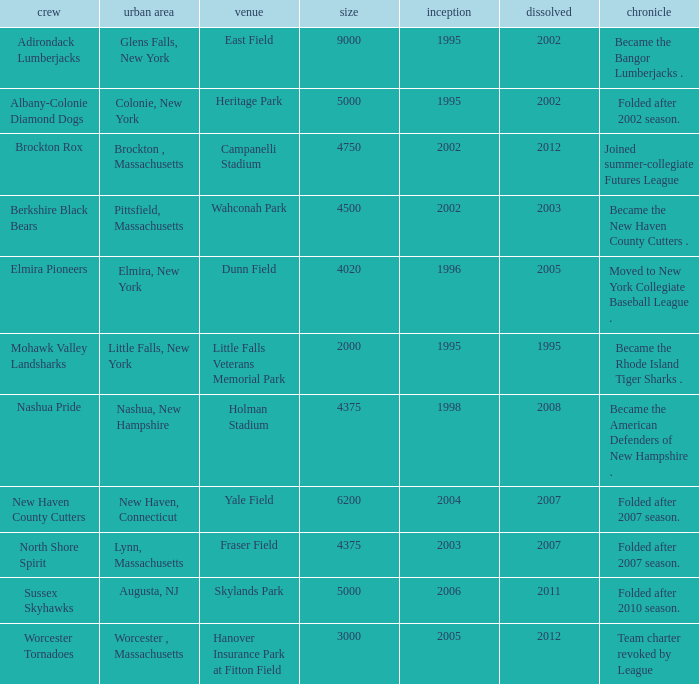What is the maximum founded year of the Worcester Tornadoes? 2005.0. 